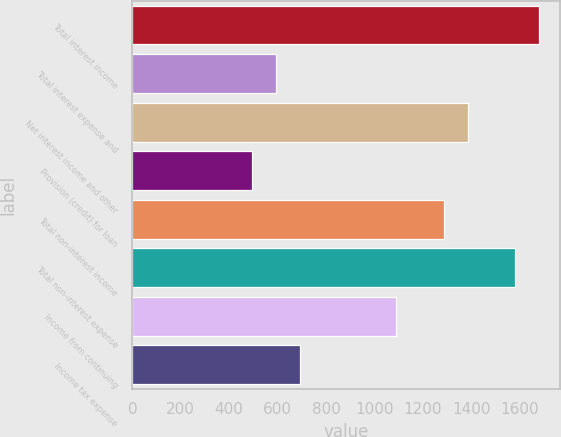Convert chart. <chart><loc_0><loc_0><loc_500><loc_500><bar_chart><fcel>Total interest income<fcel>Total interest expense and<fcel>Net interest income and other<fcel>Provision (credit) for loan<fcel>Total non-interest income<fcel>Total non-interest expense<fcel>Income from continuing<fcel>Income tax expense<nl><fcel>1681.2<fcel>593.41<fcel>1384.53<fcel>494.52<fcel>1285.64<fcel>1582.31<fcel>1087.86<fcel>692.3<nl></chart> 